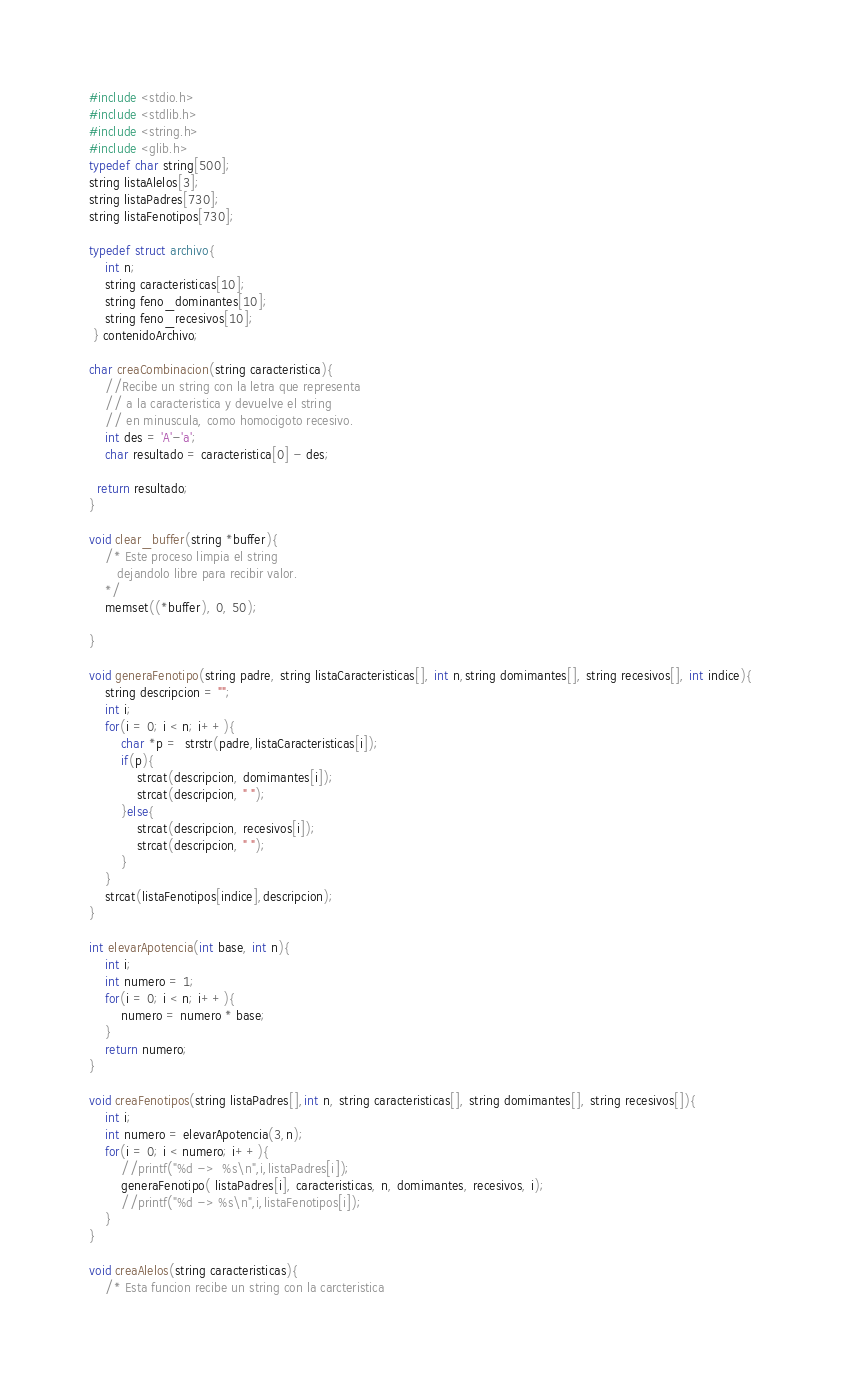Convert code to text. <code><loc_0><loc_0><loc_500><loc_500><_C_>#include <stdio.h>
#include <stdlib.h>
#include <string.h>
#include <glib.h>
typedef char string[500];
string listaAlelos[3];
string listaPadres[730];
string listaFenotipos[730];

typedef struct archivo{
    int n;
 	string caracteristicas[10];
 	string feno_dominantes[10];
 	string feno_recesivos[10];
 } contenidoArchivo;

char creaCombinacion(string caracteristica){
    //Recibe un string con la letra que representa
    // a la caracteristica y devuelve el string
    // en minuscula, como homocigoto recesivo.
    int des = 'A'-'a';
    char resultado = caracteristica[0] - des;

  return resultado;
}

void clear_buffer(string *buffer){
	/* Este proceso limpia el string
	   dejandolo libre para recibir valor. 
	*/
	memset((*buffer), 0, 50);
       
}

void generaFenotipo(string padre, string listaCaracteristicas[], int n,string domimantes[], string recesivos[], int indice){
    string descripcion = "";
    int i;
    for(i = 0; i < n; i++){
        char *p =  strstr(padre,listaCaracteristicas[i]);
        if(p){
            strcat(descripcion, domimantes[i]);
            strcat(descripcion, " ");
        }else{
            strcat(descripcion, recesivos[i]);
            strcat(descripcion, " ");
        }
    }
    strcat(listaFenotipos[indice],descripcion);
}

int elevarApotencia(int base, int n){
    int i;
    int numero = 1;
    for(i = 0; i < n; i++){
        numero = numero * base;
    }
    return numero;
}

void creaFenotipos(string listaPadres[],int n, string caracteristicas[], string domimantes[], string recesivos[]){
    int i;
    int numero = elevarApotencia(3,n);
    for(i = 0; i < numero; i++){
        //printf("%d ->  %s\n",i,listaPadres[i]);
        generaFenotipo( listaPadres[i], caracteristicas, n, domimantes, recesivos, i);
        //printf("%d -> %s\n",i,listaFenotipos[i]);
    }
}

void creaAlelos(string caracteristicas){
    /* Esta funcion recibe un string con la carcteristica</code> 